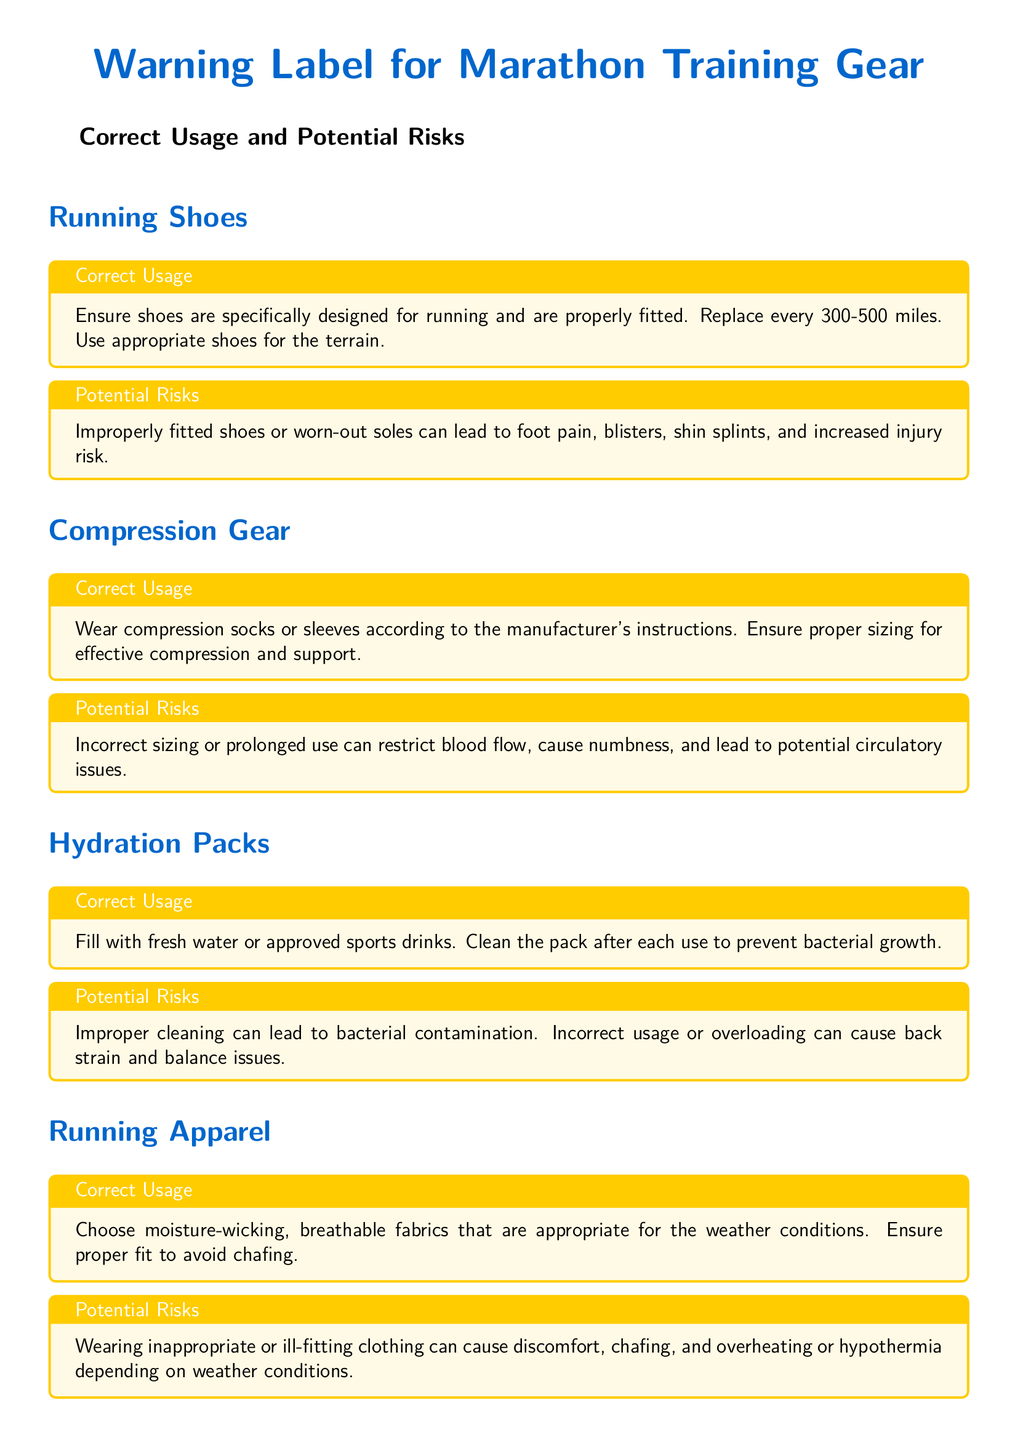What is the maximum mileage for replacing running shoes? The document states that running shoes should be replaced every 300-500 miles.
Answer: 300-500 miles What can worn-out soles of shoes lead to? The potential risks section mentions that worn-out soles can lead to foot pain, blisters, shin splints, and increased injury risk.
Answer: Foot pain, blisters, shin splints, increased injury risk What is a critical aspect of using compression gear? The correct usage section emphasizes the importance of ensuring proper sizing for effective compression and support.
Answer: Proper sizing What might happen due to improper cleaning of hydration packs? The potential risks section indicates that improper cleaning can lead to bacterial contamination.
Answer: Bacterial contamination What should users of electronic devices follow? The correct usage section advises users to use these devices as per manufacturer guidelines.
Answer: Manufacturer guidelines What is an essential precaution for recovering individuals? The important safety information section stresses consulting with healthcare professionals before introducing new gear.
Answer: Consult with healthcare professionals What type of fabric is recommended for running apparel? The correct usage section specifies choosing moisture-wicking, breathable fabrics.
Answer: Moisture-wicking, breathable fabrics What can cause numbness when using compression gear? The potential risks section states that incorrect sizing can lead to numbness.
Answer: Incorrect sizing What does the document include at the end? The document contains an important safety information box with critical advice.
Answer: Important safety information box 